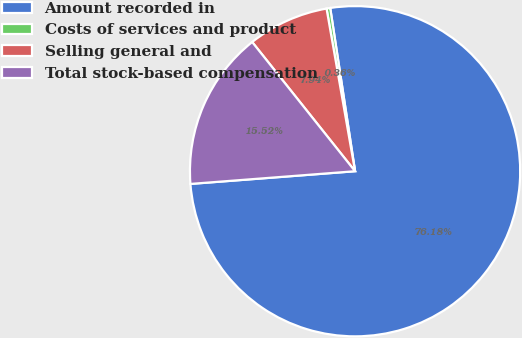Convert chart to OTSL. <chart><loc_0><loc_0><loc_500><loc_500><pie_chart><fcel>Amount recorded in<fcel>Costs of services and product<fcel>Selling general and<fcel>Total stock-based compensation<nl><fcel>76.17%<fcel>0.36%<fcel>7.94%<fcel>15.52%<nl></chart> 